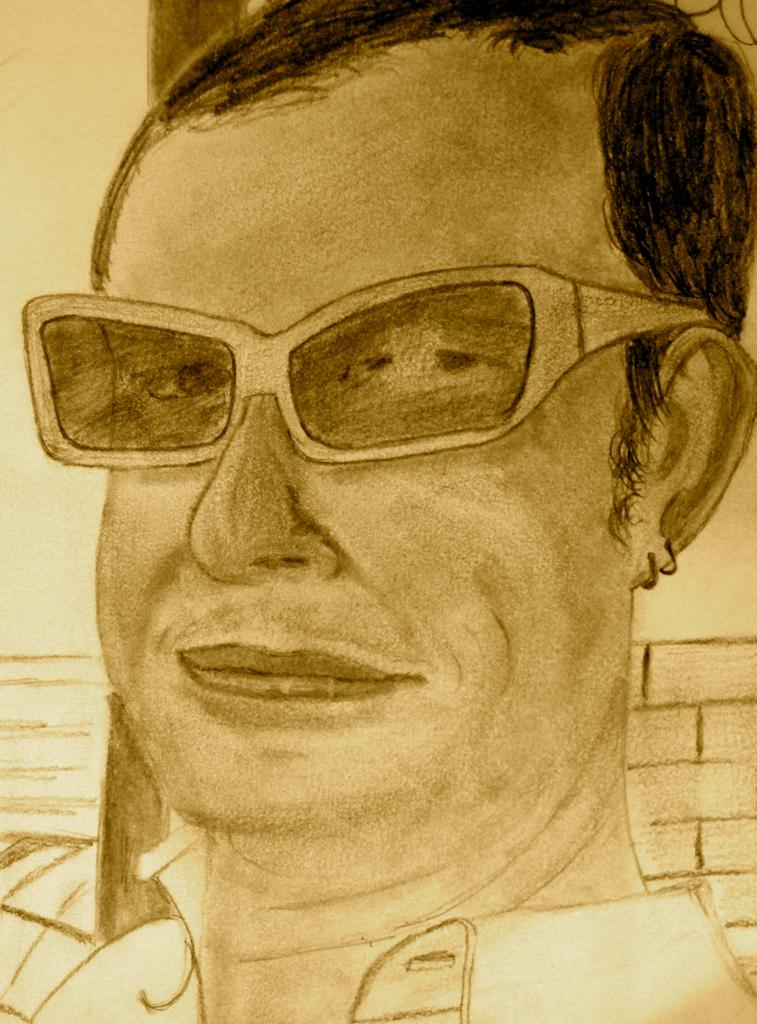What is the main subject of the image? There is a painting in the image. What does the painting depict? The painting depicts a person. What type of ant can be seen crawling on the person in the painting? There is no ant present in the painting; it depicts a person without any insects. Is there a ghost visible in the painting? There is no ghost present in the painting; it depicts a person without any supernatural beings. 